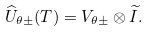Convert formula to latex. <formula><loc_0><loc_0><loc_500><loc_500>\widehat { U } _ { \theta \pm } ( T ) = V _ { \theta \pm } \otimes \widetilde { I } .</formula> 